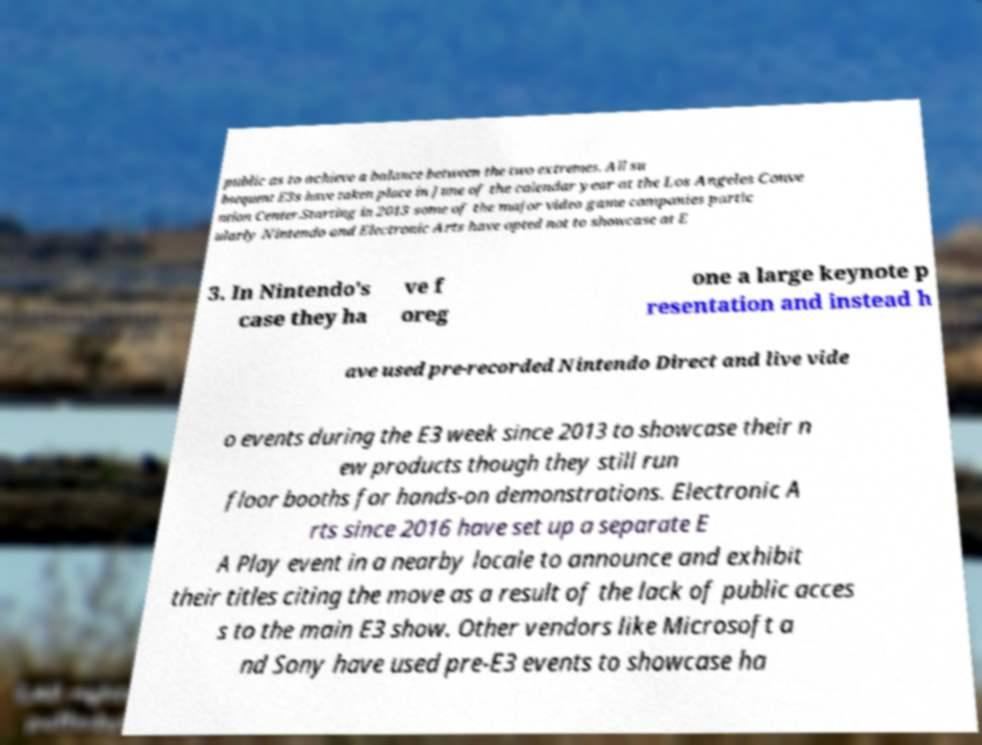Please identify and transcribe the text found in this image. public as to achieve a balance between the two extremes. All su bsequent E3s have taken place in June of the calendar year at the Los Angeles Conve ntion Center.Starting in 2013 some of the major video game companies partic ularly Nintendo and Electronic Arts have opted not to showcase at E 3. In Nintendo's case they ha ve f oreg one a large keynote p resentation and instead h ave used pre-recorded Nintendo Direct and live vide o events during the E3 week since 2013 to showcase their n ew products though they still run floor booths for hands-on demonstrations. Electronic A rts since 2016 have set up a separate E A Play event in a nearby locale to announce and exhibit their titles citing the move as a result of the lack of public acces s to the main E3 show. Other vendors like Microsoft a nd Sony have used pre-E3 events to showcase ha 